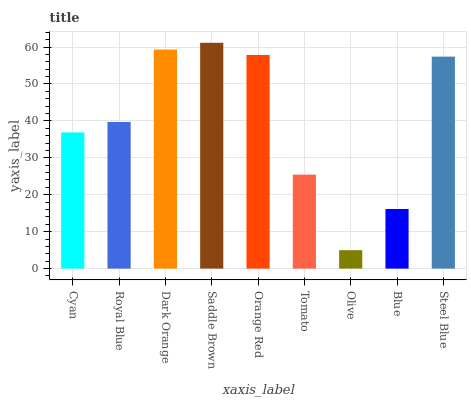Is Olive the minimum?
Answer yes or no. Yes. Is Saddle Brown the maximum?
Answer yes or no. Yes. Is Royal Blue the minimum?
Answer yes or no. No. Is Royal Blue the maximum?
Answer yes or no. No. Is Royal Blue greater than Cyan?
Answer yes or no. Yes. Is Cyan less than Royal Blue?
Answer yes or no. Yes. Is Cyan greater than Royal Blue?
Answer yes or no. No. Is Royal Blue less than Cyan?
Answer yes or no. No. Is Royal Blue the high median?
Answer yes or no. Yes. Is Royal Blue the low median?
Answer yes or no. Yes. Is Dark Orange the high median?
Answer yes or no. No. Is Dark Orange the low median?
Answer yes or no. No. 